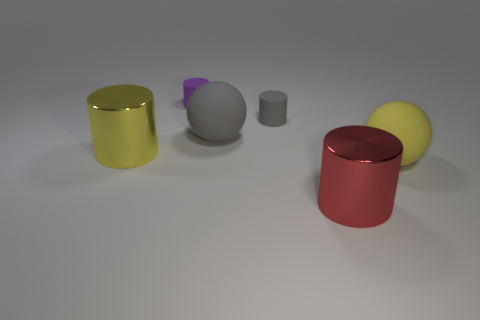Add 4 gray cylinders. How many objects exist? 10 Subtract all cylinders. How many objects are left? 2 Add 1 tiny rubber things. How many tiny rubber things are left? 3 Add 6 red cylinders. How many red cylinders exist? 7 Subtract 0 brown cylinders. How many objects are left? 6 Subtract all tiny purple shiny things. Subtract all large gray matte objects. How many objects are left? 5 